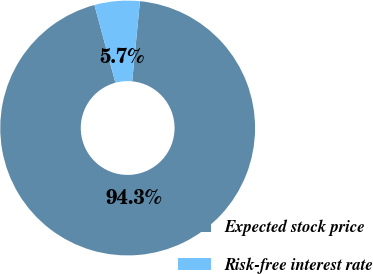Convert chart to OTSL. <chart><loc_0><loc_0><loc_500><loc_500><pie_chart><fcel>Expected stock price<fcel>Risk-free interest rate<nl><fcel>94.26%<fcel>5.74%<nl></chart> 